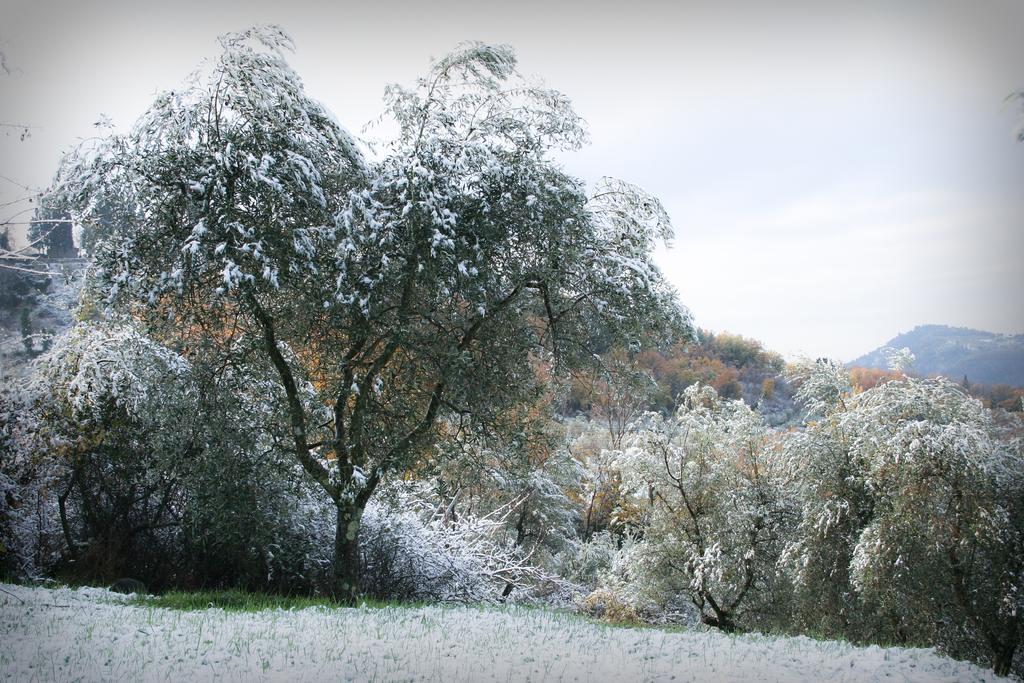How would you summarize this image in a sentence or two? In this image we can see a group of trees with snow. In the foreground we can see the grass. On the right side of the image we can see the mountain. At the top there is a sky. 